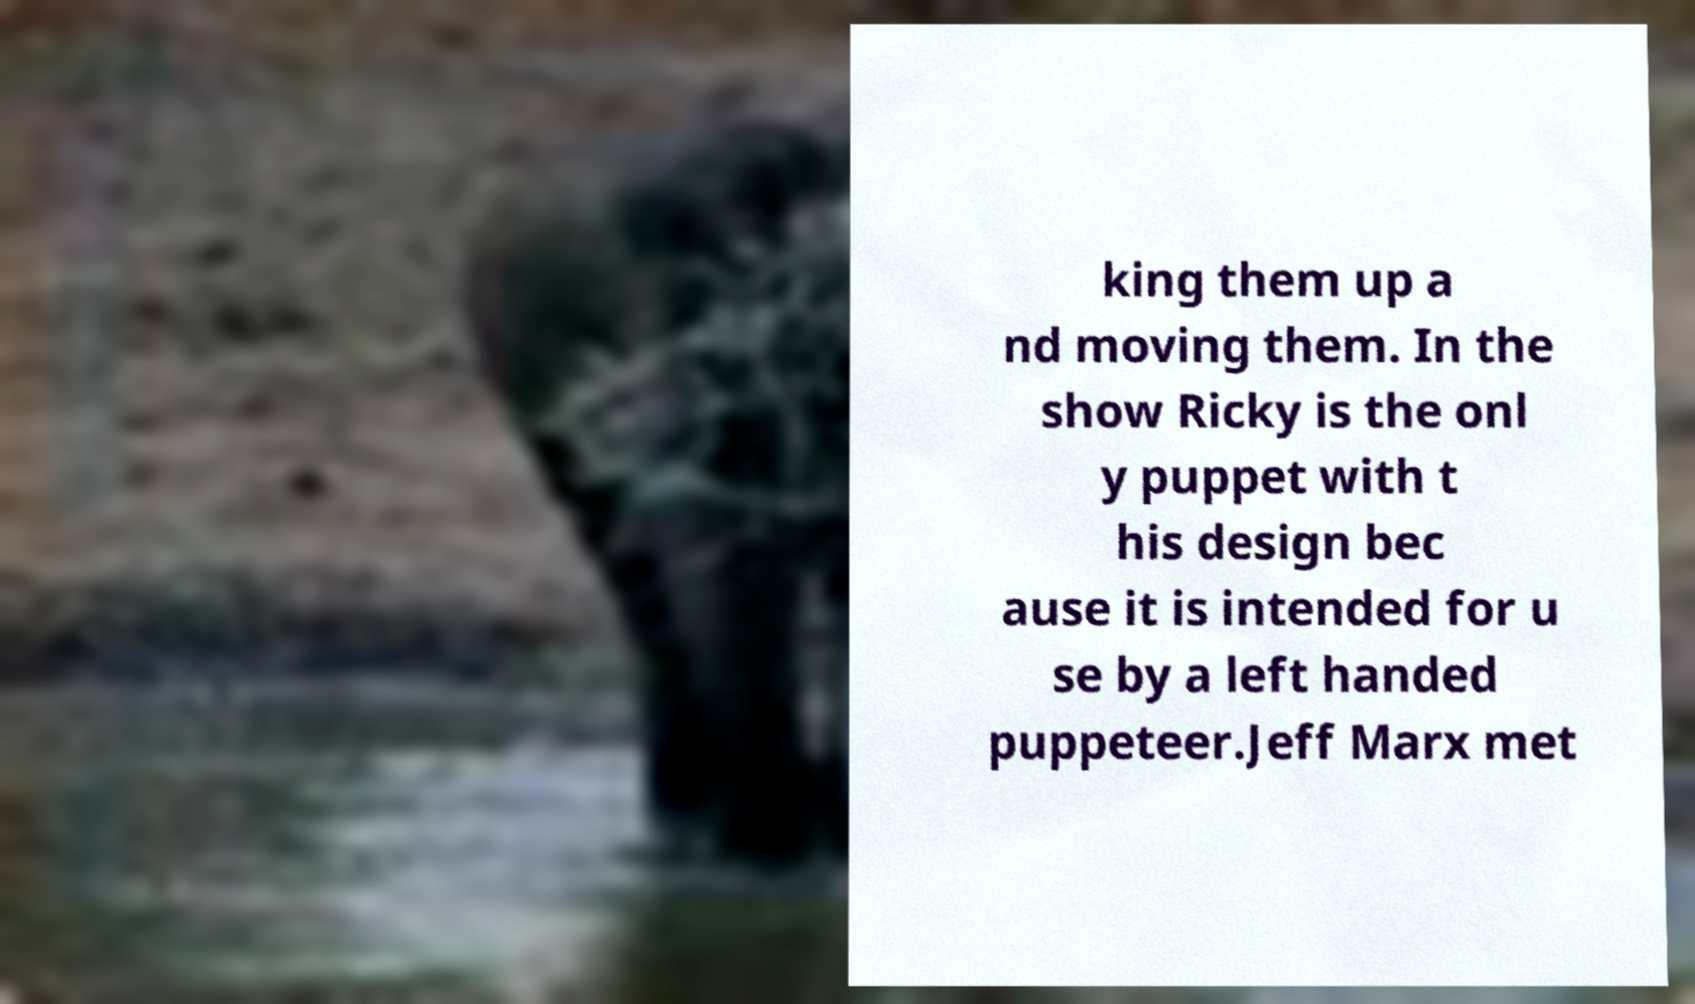Can you accurately transcribe the text from the provided image for me? king them up a nd moving them. In the show Ricky is the onl y puppet with t his design bec ause it is intended for u se by a left handed puppeteer.Jeff Marx met 